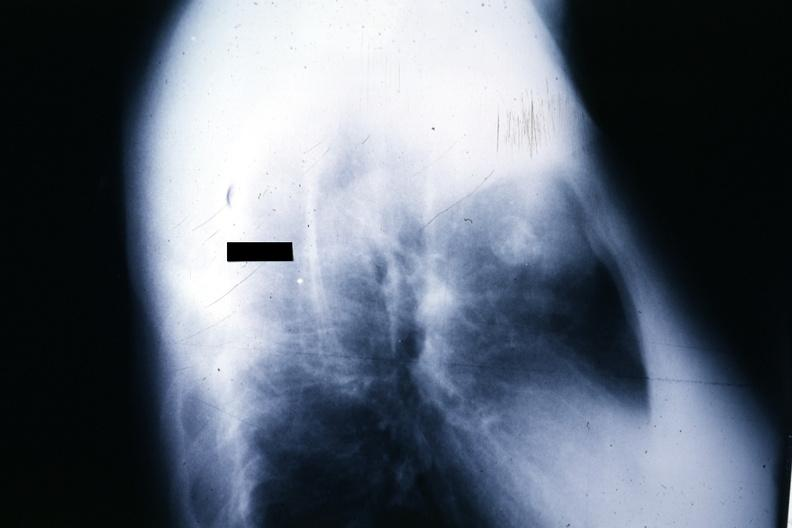does this image show x-ray lateral view large mass anterior superior mediastinum source?
Answer the question using a single word or phrase. Yes 